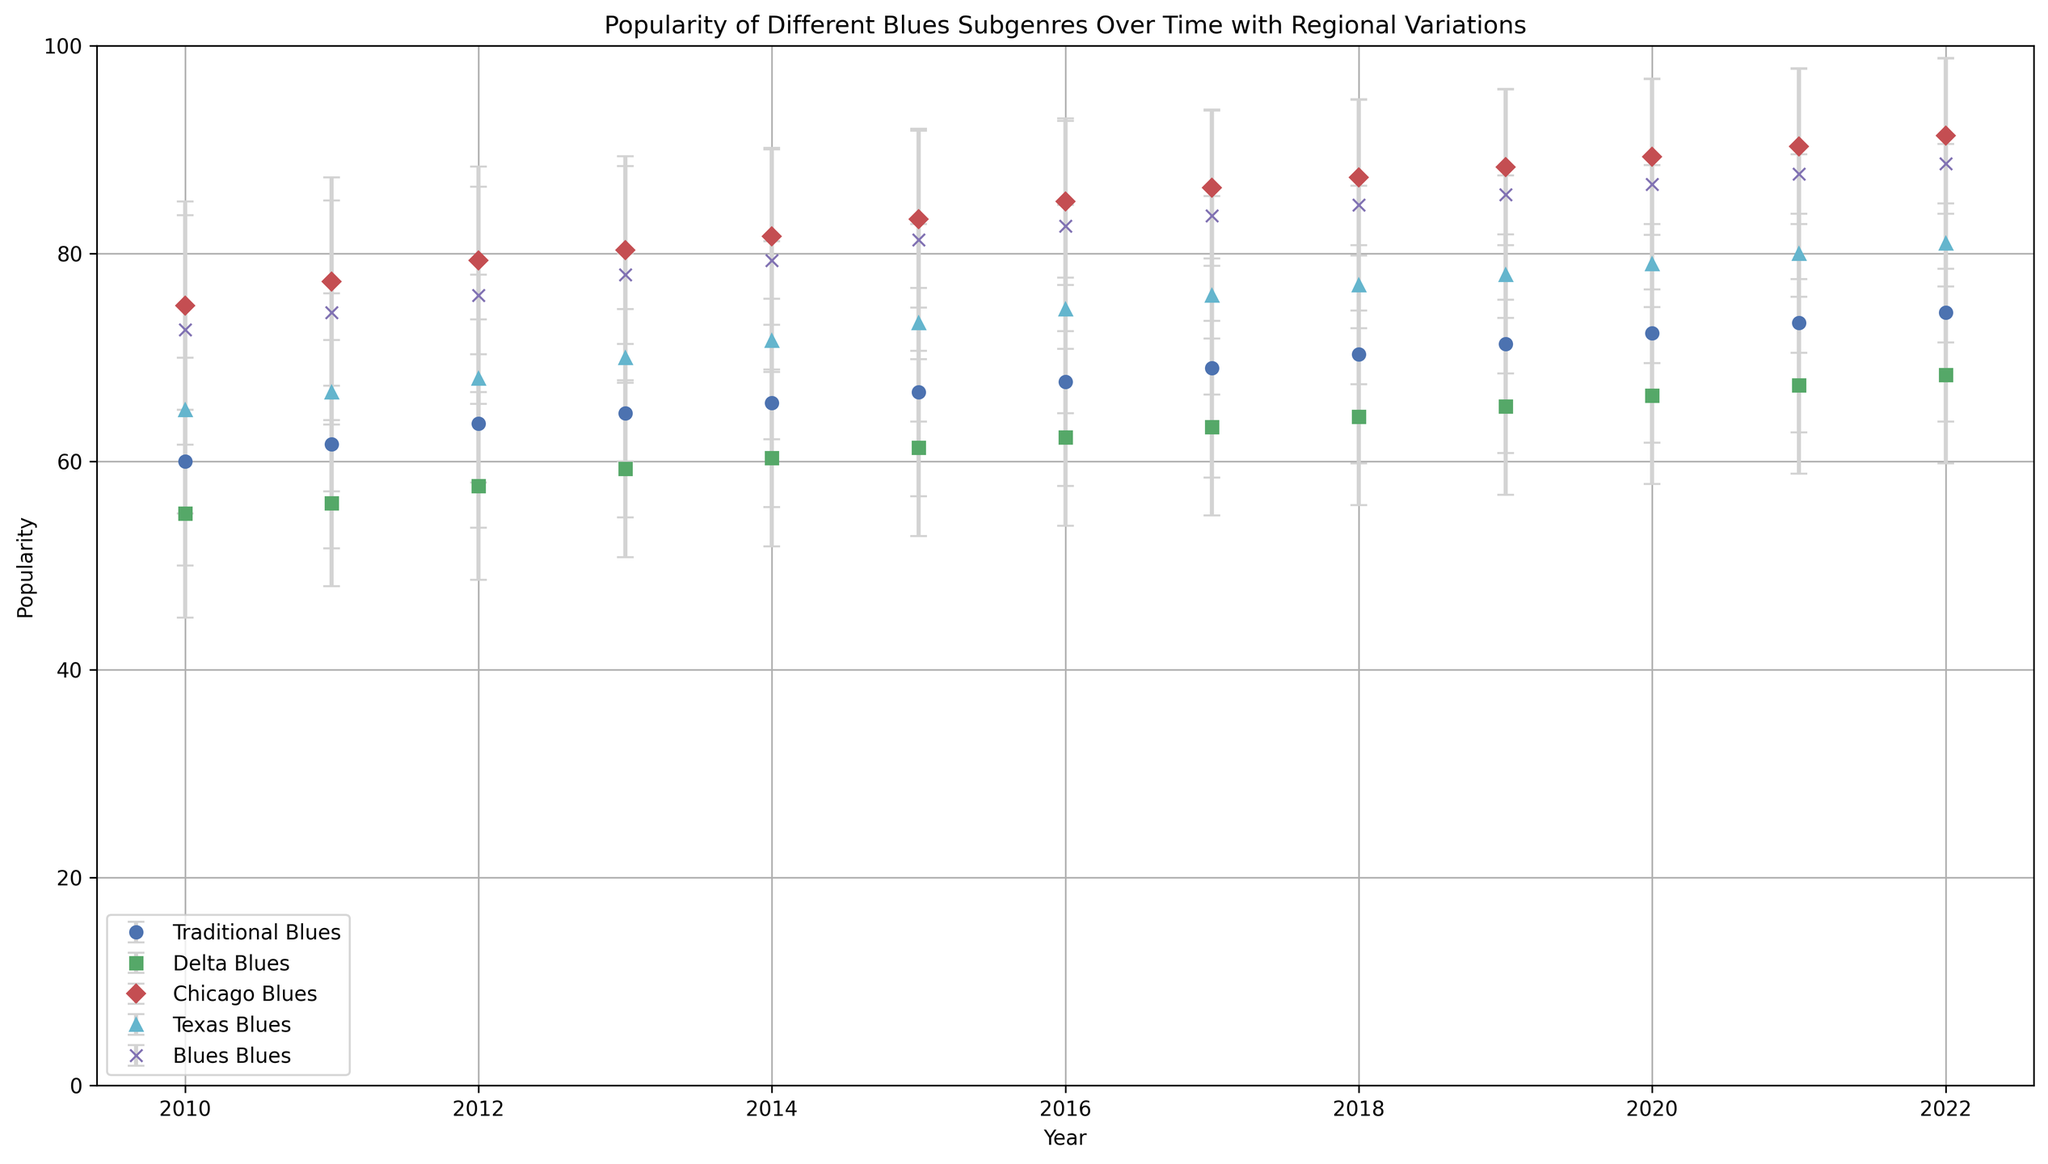Which blues subgenre has the highest average popularity across all years? Look at all the lines on the plot and identify which one has the highest average point values over all years. The "Chicago Blues" line consistently has the highest points.
Answer: Chicago Blues Which region contributes to the largest error bars for Delta Blues over time? Analyze the error bars of the Delta Blues line on the plot. Notice that error bars for Delta Blues are generally larger when considering variations between regions.
Answer: Asia In which year did the Traditional Blues popularity reach its peak? Follow the Traditional Blues line (blue points) and identify the highest point on the plot. The peak for Traditional Blues is in the year 2022.
Answer: 2022 How does the popularity of Blues Rock in North America in 2018 compare with its popularity in Europe in 2018? Locate the 2018 marker for the Blues Rock line (magenta points) and compare the values for North America and Europe. Blues Rock popularity in North America is higher than in Europe for 2018.
Answer: Higher What is the difference between the highest and lowest popularity values for Chicago Blues in the years displayed? Identify the highest and lowest points on the Chicago Blues (red points) line. The highest is 99 (2022), and the lowest is 65 (2010), so the difference is 99 - 65.
Answer: 34 Which year has the lowest popularity standard deviation for Texas Blues? Observe the error bars (length of the caps) for Texas Blues (cyan points) on the plot. Shorter error bars indicate lower standard deviation. Identify the year with the shortest error bar.
Answer: 2013 What is the average popularity of Delta Blues in 2010 and 2022 across all regions? Extract the Delta Blues popularity values for 2010 and 2022, then sum them and divide by total numbers. (65+55+45) in 2010 and (77+68+60) in 2022. Average is (165/3 + 205/3) / 2.
Answer: 61 (rounded) Which blues subgenre shows the most consistent increase in popularity over the years? Follow each subgenre's line and observe the trend. The line for Blues Rock (magenta points) shows a consistent upward trend without significant fluctuations.
Answer: Blues Rock During which year are the regional variations for Traditional Blues the highest, based on the error bars? Examine the lengths of the error bars for the Traditional Blues line (blue points) and find the longest one. The longest error bar appears around 2013.
Answer: 2013 How did Texas Blues's popularity in Asia change from 2010 to 2022? Compare the Asian values of Texas Blues for 2010 and 2022 as indicated by the plot. Popularity increased from 55 (2010) to 72 (2022).
Answer: Increased 